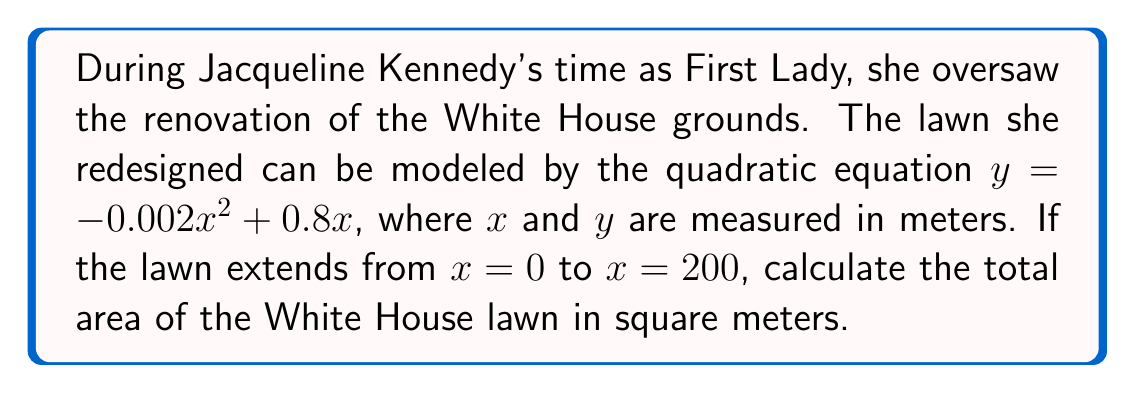Solve this math problem. To find the area under a quadratic function, we need to use integration:

1) The area is given by the definite integral:
   $$A = \int_0^{200} (-0.002x^2 + 0.8x) dx$$

2) Integrate the function:
   $$A = \left[-\frac{0.002x^3}{3} + 0.4x^2\right]_0^{200}$$

3) Evaluate the integral at the limits:
   $$A = \left(-\frac{0.002(200)^3}{3} + 0.4(200)^2\right) - \left(-\frac{0.002(0)^3}{3} + 0.4(0)^2\right)$$

4) Simplify:
   $$A = (-5333.33 + 16000) - (0)$$
   $$A = 10666.67$$

5) Round to the nearest whole number:
   $$A ≈ 10667 \text{ square meters}$$
Answer: 10667 m² 